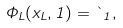Convert formula to latex. <formula><loc_0><loc_0><loc_500><loc_500>\Phi _ { L } ( x _ { L } , 1 ) = \theta _ { 1 } ,</formula> 